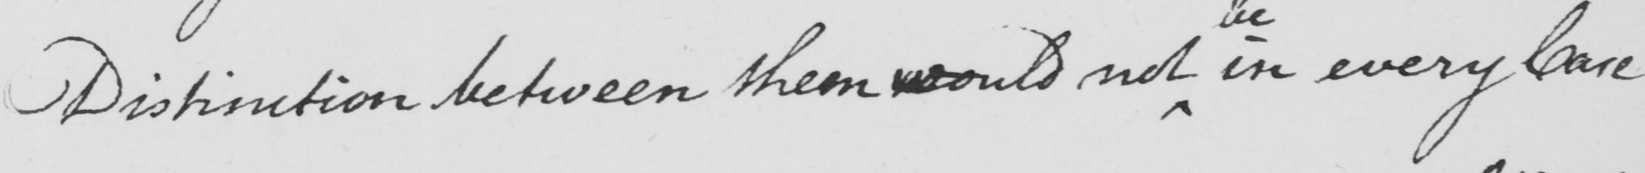What is written in this line of handwriting? Distinction between them would not in every Care 